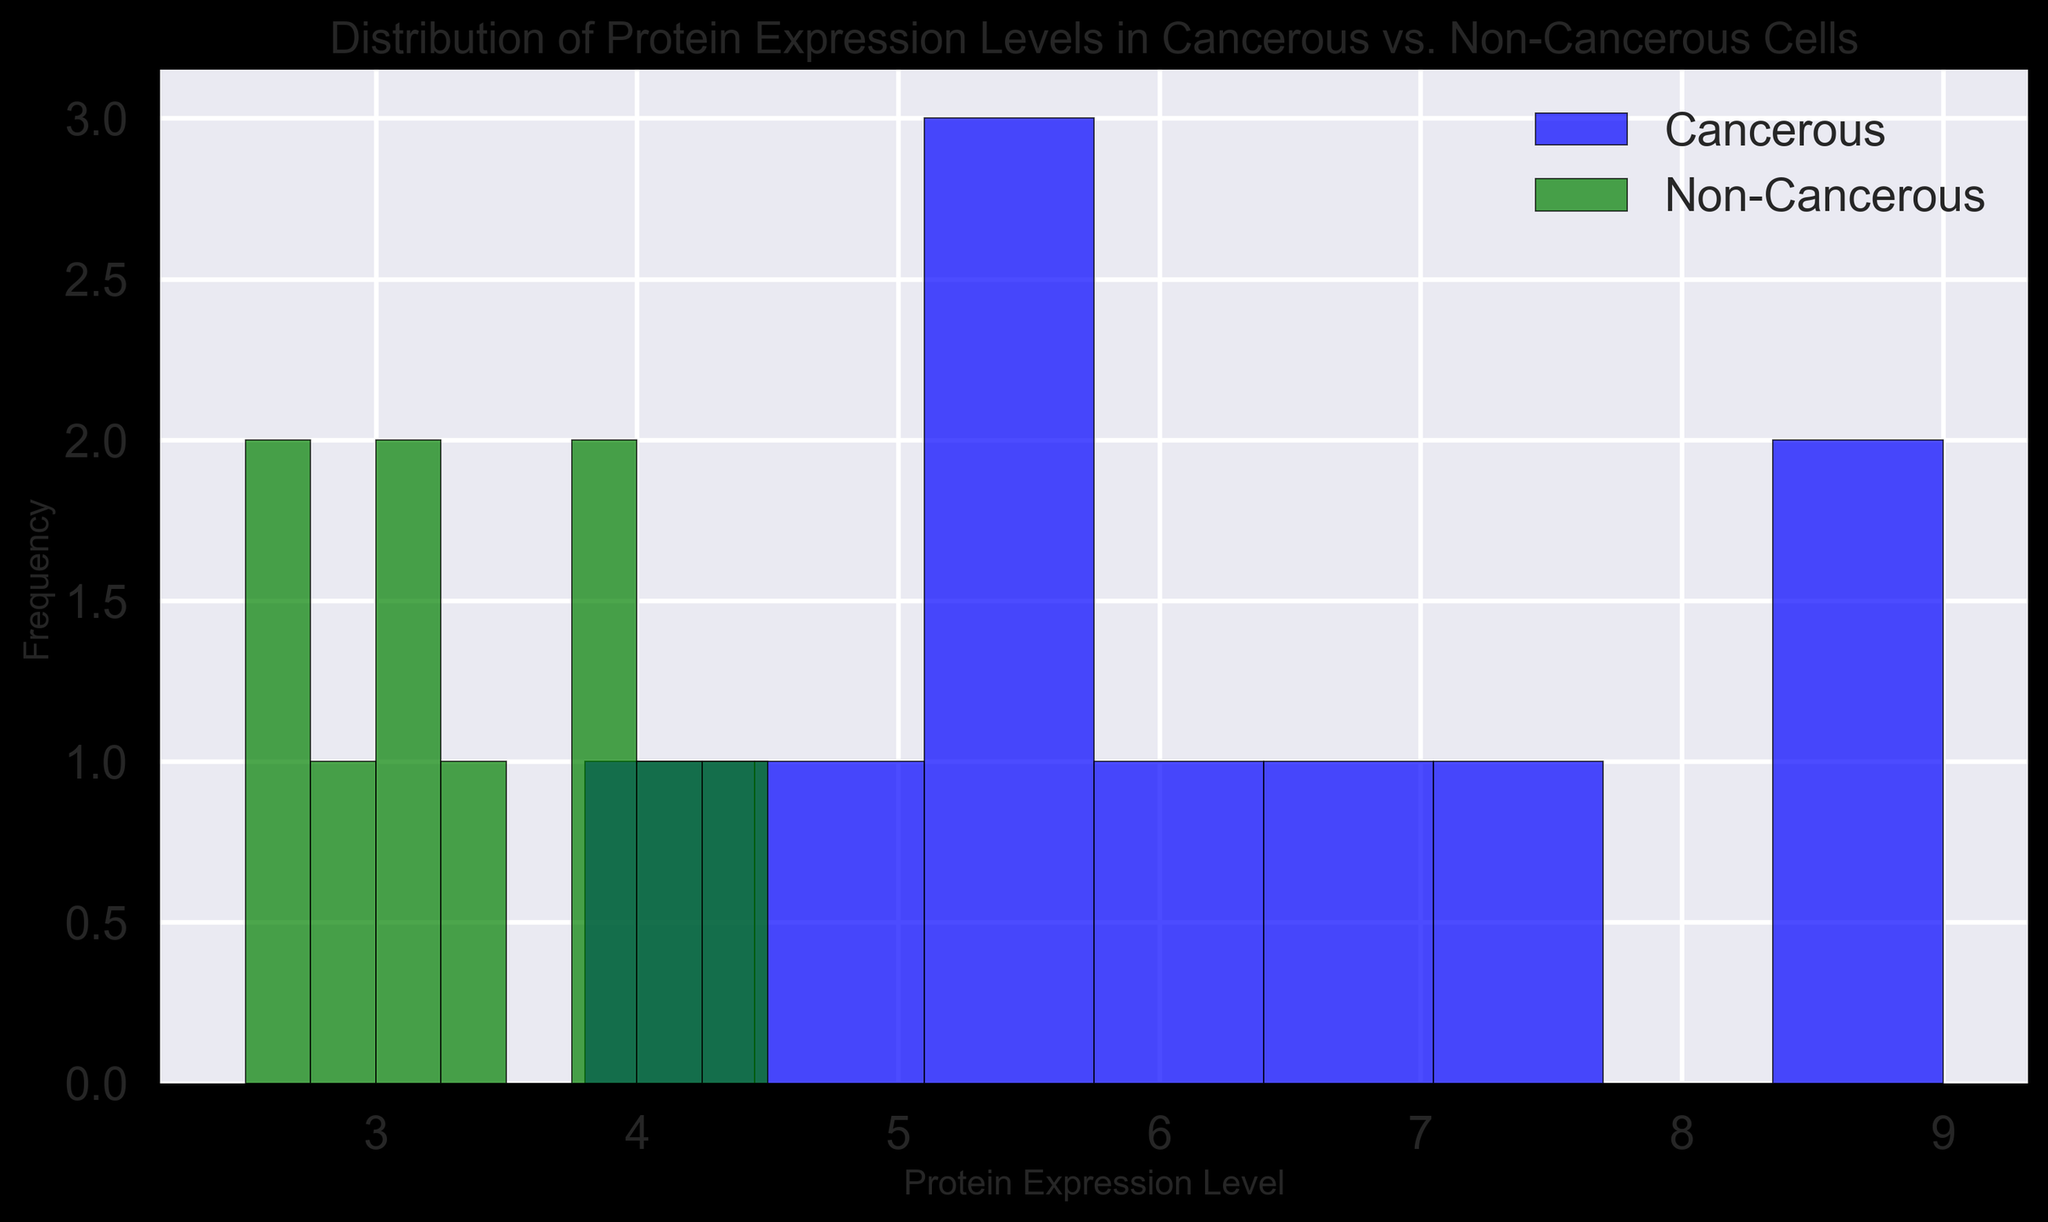What is the most frequent range of protein expression levels in cancerous cells? By looking at the histogram, identify the bin (range of values) with the highest bar for cancerous cells.
Answer: 5.0-6.0 How does the frequency of protein expression levels in the 4.0-5.0 range compare between cancerous and non-cancerous cells? Compare the height of the bars in the 4.0-5.0 range for both cancerous (blue) and non-cancerous (green) cells to see which one is taller.
Answer: Higher for cancerous What is the approximate range of the lowest protein expression levels in non-cancerous cells? Look for the first bin (the lowest range) on the histogram for non-cancerous cells (green bars).
Answer: 2.0-3.0 By how much does the highest bar for non-cancerous cells exceed the highest bar for cancerous cells? Identify the highest bar for each group and subtract the height of the bar for cancerous cells from the height of the bar for non-cancerous cells. Ensure to count the frequency for the highest bars visually.
Answer: 1 Which category (cancerous or non-cancerous) has a greater spread in protein expression levels? Observing the width of the distribution, check which group spans a larger range on the x-axis.
Answer: Cancerous In which range does the protein expression level overlap most for both groups? Identify where both the blue and green bars are seen together at similar heights on the histogram.
Answer: 4.0-5.0 What percentage of non-cancerous cells have protein expression levels below 3.5? Count the number of bars below 3.5 for non-cancerous cells and sum their frequency, then divide by the total number of non-cancerous cells and multiply by 100 for the percentage.
Answer: 50% What is the approximate range of the highest protein expression levels in cancerous cells? Look for the last bin (the highest range) on the histogram for cancerous cells (blue bars).
Answer: 8.0-9.0 Compare the median protein expression levels between cancerous and non-cancerous cells by visual estimation. Locate the middle bar or range on the x-axis for each group (cancerous and non-cancerous) and compare their positions.
Answer: Higher in cancerous 